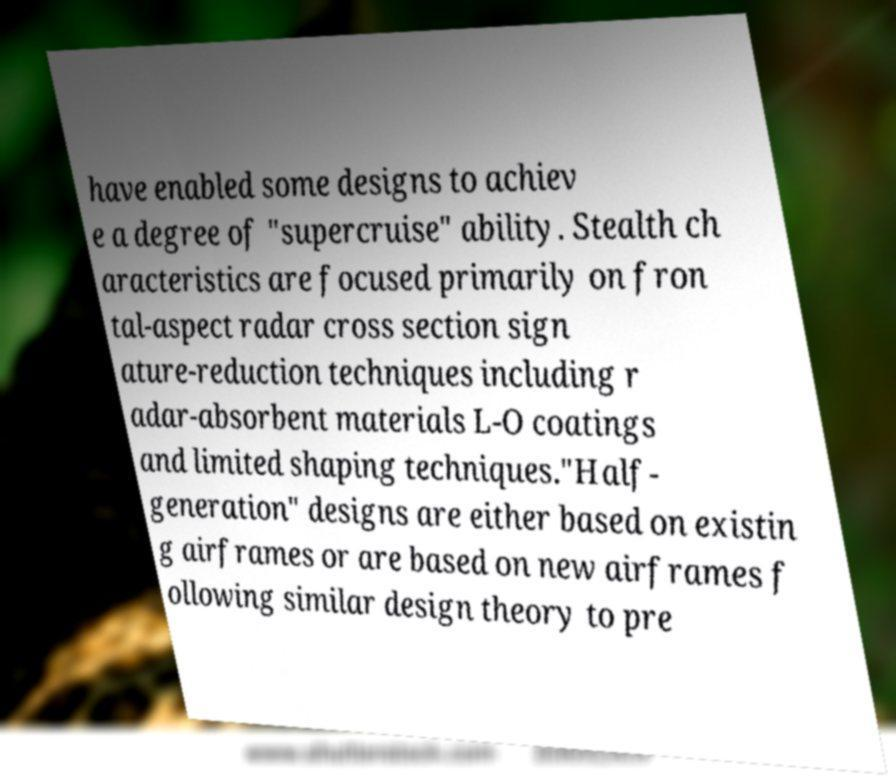I need the written content from this picture converted into text. Can you do that? have enabled some designs to achiev e a degree of "supercruise" ability. Stealth ch aracteristics are focused primarily on fron tal-aspect radar cross section sign ature-reduction techniques including r adar-absorbent materials L-O coatings and limited shaping techniques."Half- generation" designs are either based on existin g airframes or are based on new airframes f ollowing similar design theory to pre 